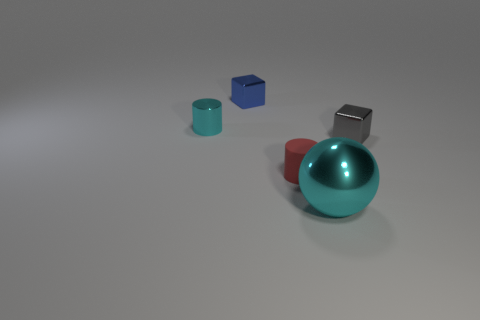Add 4 big green spheres. How many objects exist? 9 Subtract all balls. How many objects are left? 4 Subtract all blocks. Subtract all small cyan metallic cylinders. How many objects are left? 2 Add 1 shiny cubes. How many shiny cubes are left? 3 Add 2 large purple rubber spheres. How many large purple rubber spheres exist? 2 Subtract 0 yellow blocks. How many objects are left? 5 